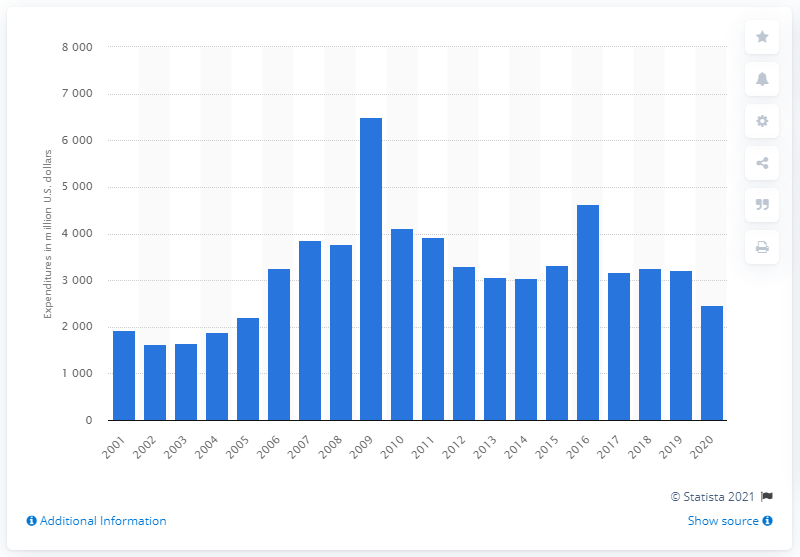When was the highest level of research and development expenditure? The highest level of research and development expenditure was in 2009, with an impressive peak surpassing 7,000 million U.S. dollars, according to the bar chart. 